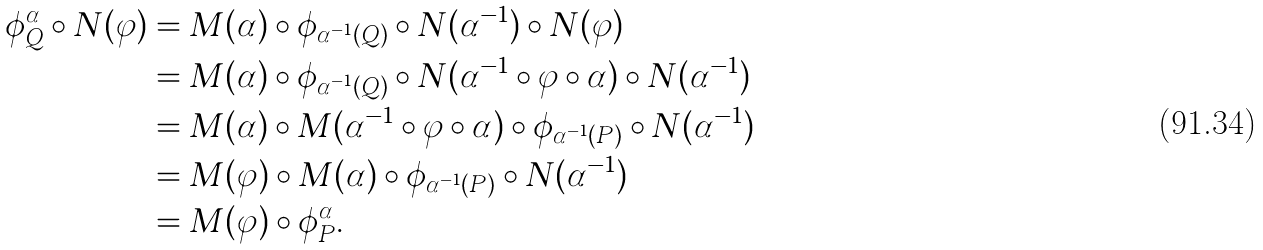Convert formula to latex. <formula><loc_0><loc_0><loc_500><loc_500>\phi ^ { \alpha } _ { Q } \circ N ( \varphi ) & = M ( \alpha ) \circ \phi _ { \alpha ^ { - 1 } ( Q ) } \circ N ( \alpha ^ { - 1 } ) \circ N ( \varphi ) \\ & = M ( \alpha ) \circ \phi _ { \alpha ^ { - 1 } ( Q ) } \circ N ( \alpha ^ { - 1 } \circ \varphi \circ \alpha ) \circ N ( \alpha ^ { - 1 } ) \\ & = M ( \alpha ) \circ M ( \alpha ^ { - 1 } \circ \varphi \circ \alpha ) \circ \phi _ { \alpha ^ { - 1 } ( P ) } \circ N ( \alpha ^ { - 1 } ) \\ & = M ( \varphi ) \circ M ( \alpha ) \circ \phi _ { \alpha ^ { - 1 } ( P ) } \circ N ( \alpha ^ { - 1 } ) \\ & = M ( \varphi ) \circ \phi ^ { \alpha } _ { P } .</formula> 